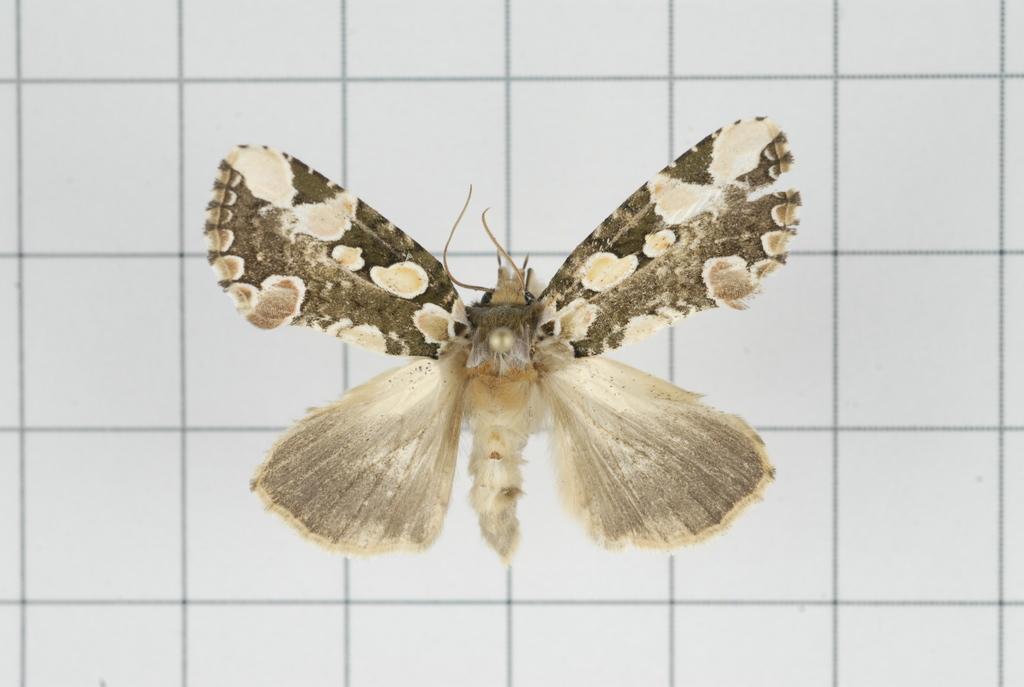Can you describe this image briefly? As we can see in the image, there is a insect on white color tiles. 